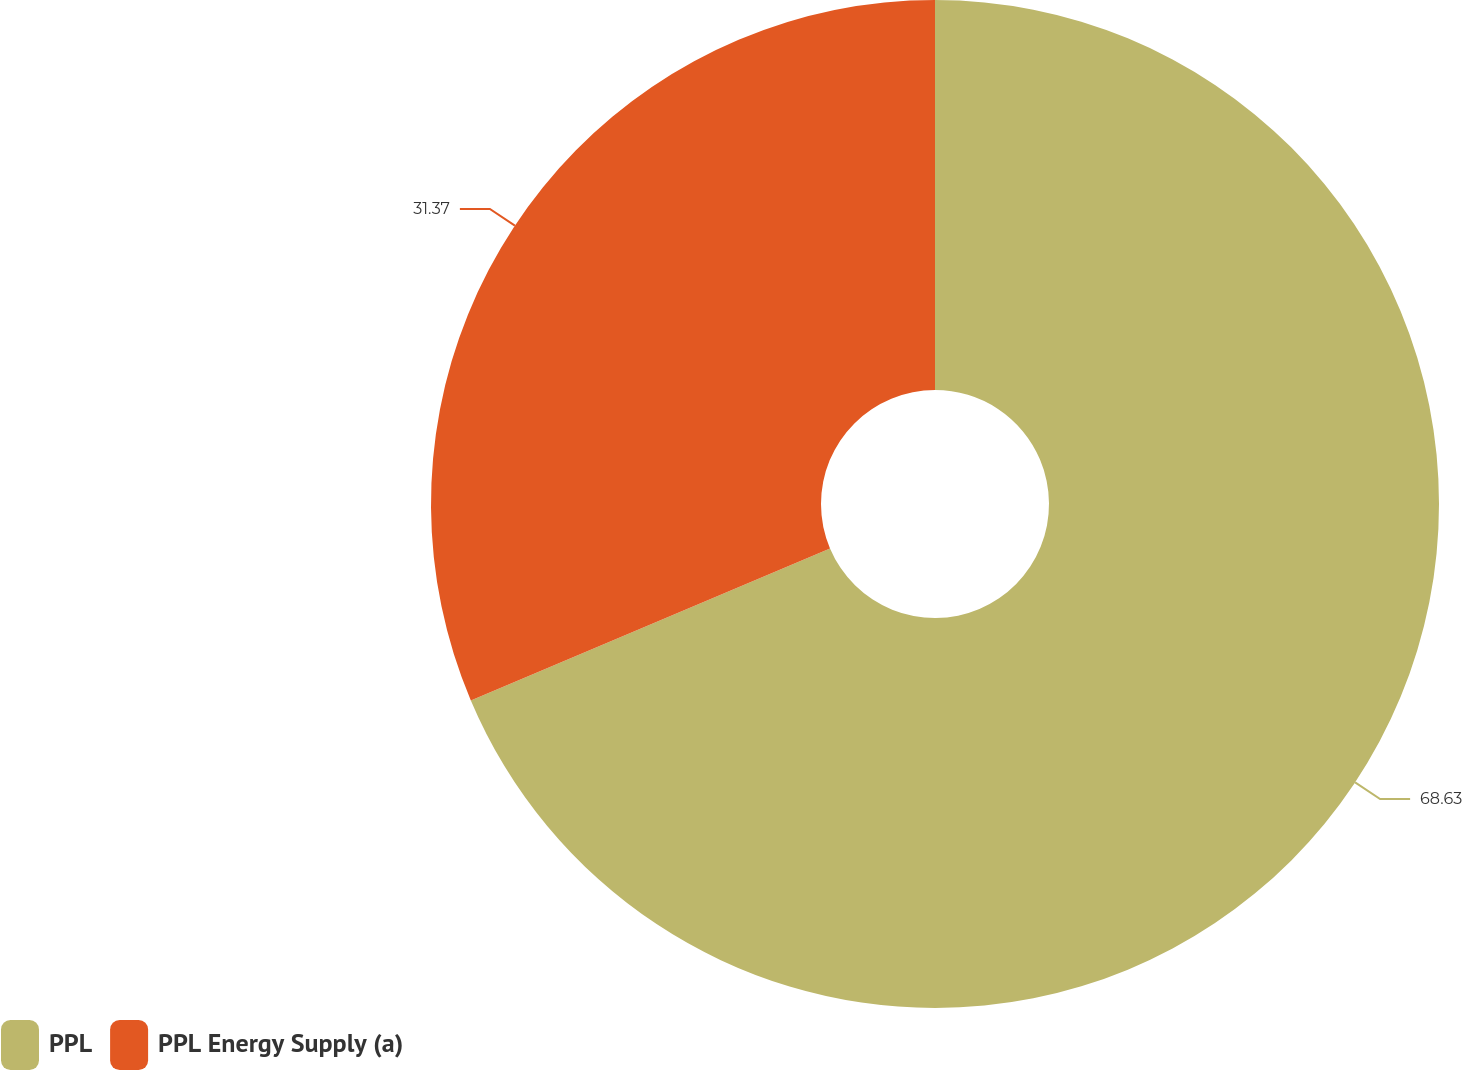Convert chart. <chart><loc_0><loc_0><loc_500><loc_500><pie_chart><fcel>PPL<fcel>PPL Energy Supply (a)<nl><fcel>68.63%<fcel>31.37%<nl></chart> 